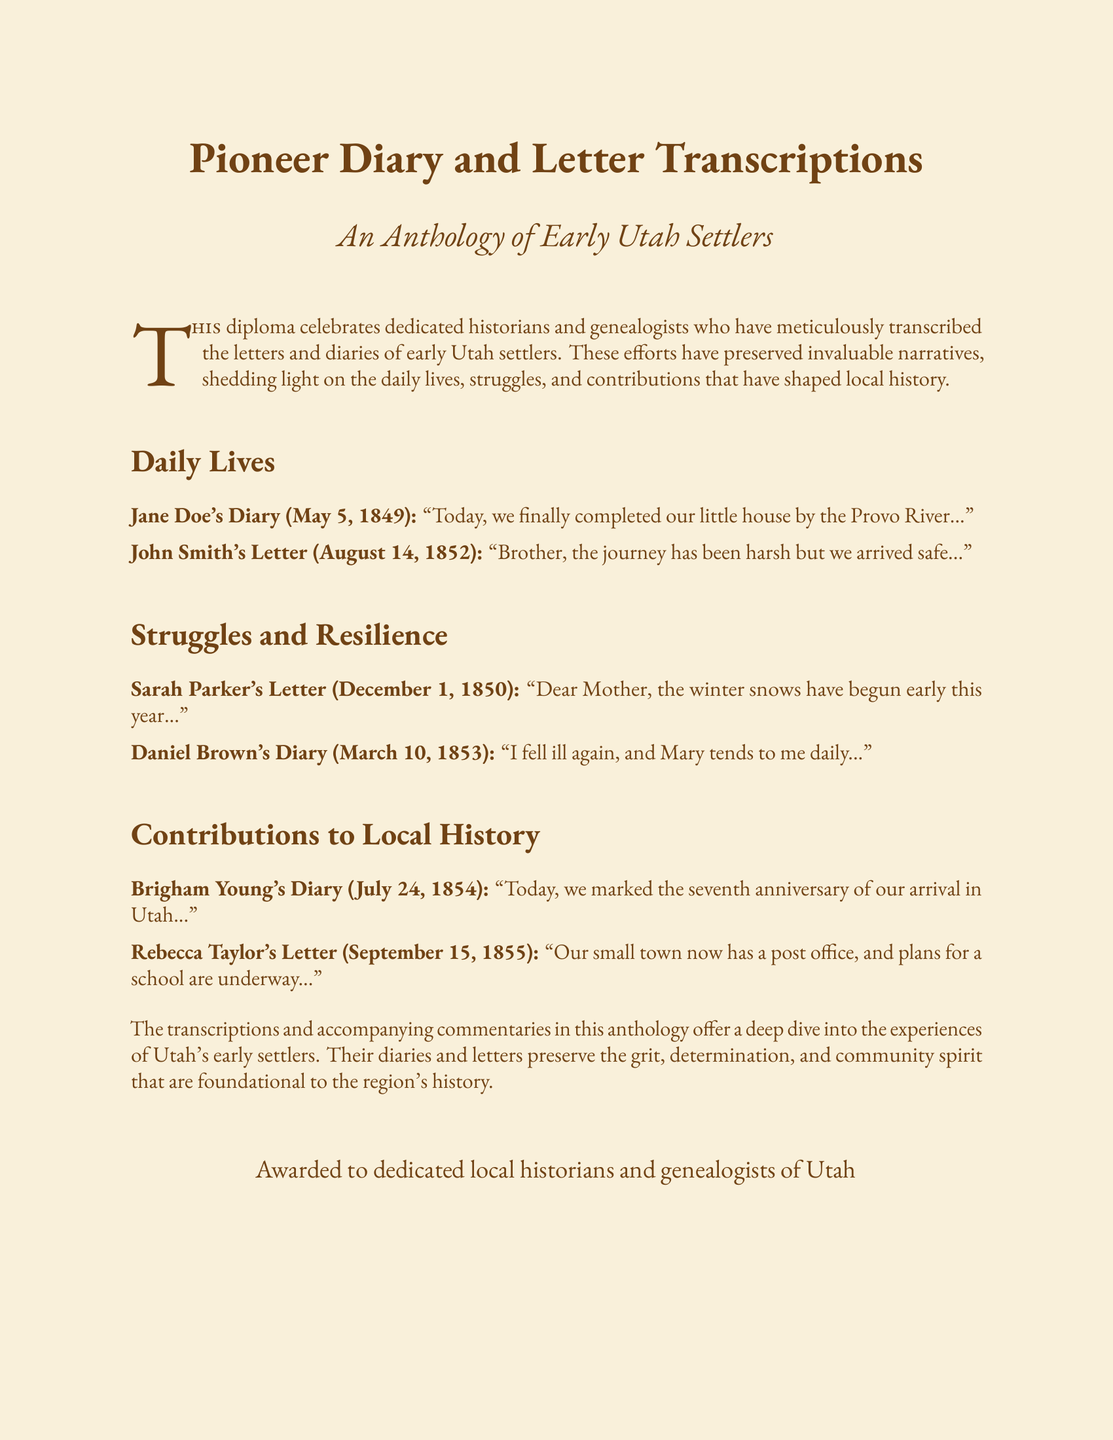What is the title of the anthology? The title of the anthology is mentioned in the diploma header.
Answer: Pioneer Diary and Letter Transcriptions Who wrote the diary entry dated May 5, 1849? The diary entry includes the name of the person who wrote it along with the date.
Answer: Jane Doe What notable event is mentioned in Brigham Young's diary entry? The diary entry references a specific anniversary related to their arrival in Utah.
Answer: Seventh anniversary In what year did Sarah Parker write her letter? The year of Sarah Parker's letter is included in the date provided in the document.
Answer: 1850 What was a struggle mentioned in Daniel Brown's diary? The diary entry refers to a personal challenge that Daniel Brown faced during his time.
Answer: Illness What future plans were mentioned in Rebecca Taylor's letter? The letter discusses developments for the community mentioned in her correspondence.
Answer: School plans Which river is mentioned in Jane Doe's diary? The river included in Jane Doe's diary entry identifies a specific geographic feature.
Answer: Provo River What does the anthology highlight about early Utah settlers? The introductory statement describes what the anthology specifically emphasizes regarding settlers.
Answer: Daily lives, struggles, and contributions Who is awarded the diploma? The closing section of the document identifies the recipients of the diploma.
Answer: Dedicated local historians and genealogists of Utah 